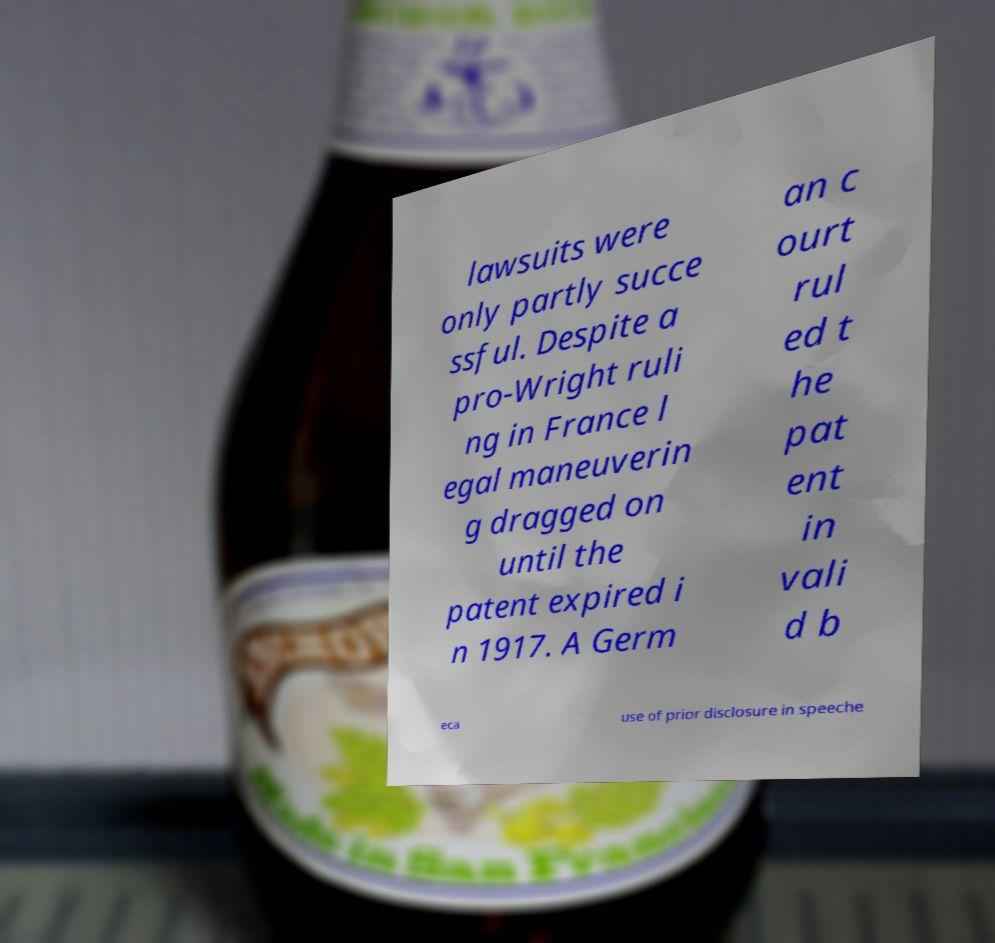What messages or text are displayed in this image? I need them in a readable, typed format. lawsuits were only partly succe ssful. Despite a pro-Wright ruli ng in France l egal maneuverin g dragged on until the patent expired i n 1917. A Germ an c ourt rul ed t he pat ent in vali d b eca use of prior disclosure in speeche 